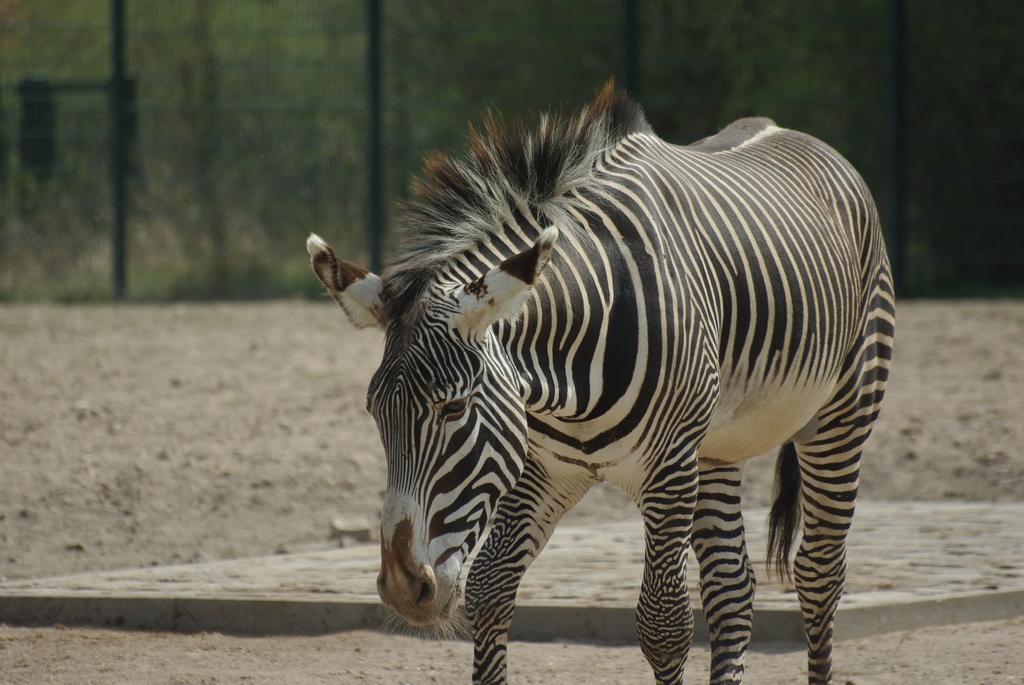Describe this image in one or two sentences. Here I can see a zebra is walking on the ground. In the background there is a net fencing, behind there are few plants. 